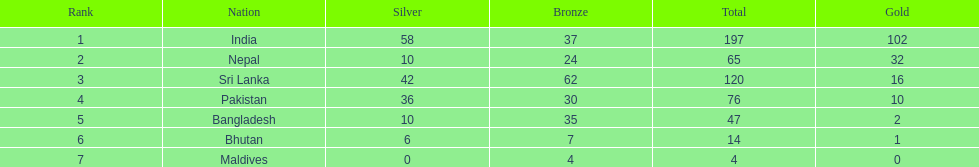How many countries have one more than 10 gold medals? 3. 